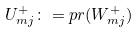Convert formula to latex. <formula><loc_0><loc_0><loc_500><loc_500>U _ { m j } ^ { + } \colon = p r ( W _ { m j } ^ { + } )</formula> 